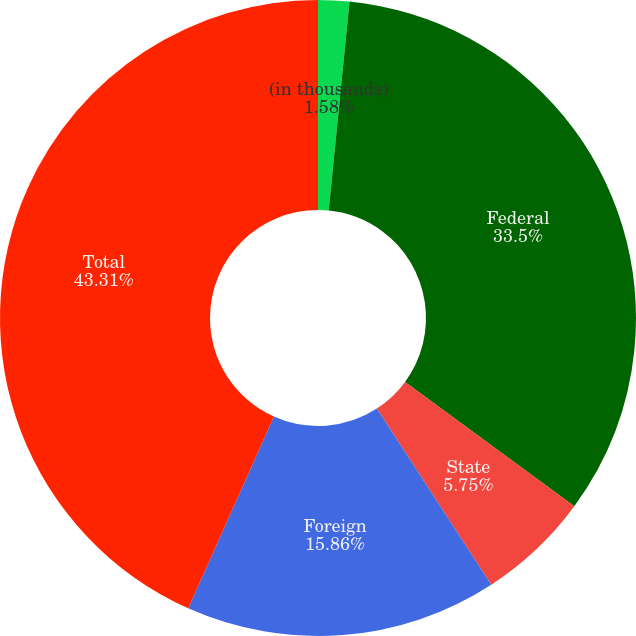Convert chart. <chart><loc_0><loc_0><loc_500><loc_500><pie_chart><fcel>(in thousands)<fcel>Federal<fcel>State<fcel>Foreign<fcel>Total<nl><fcel>1.58%<fcel>33.5%<fcel>5.75%<fcel>15.86%<fcel>43.31%<nl></chart> 